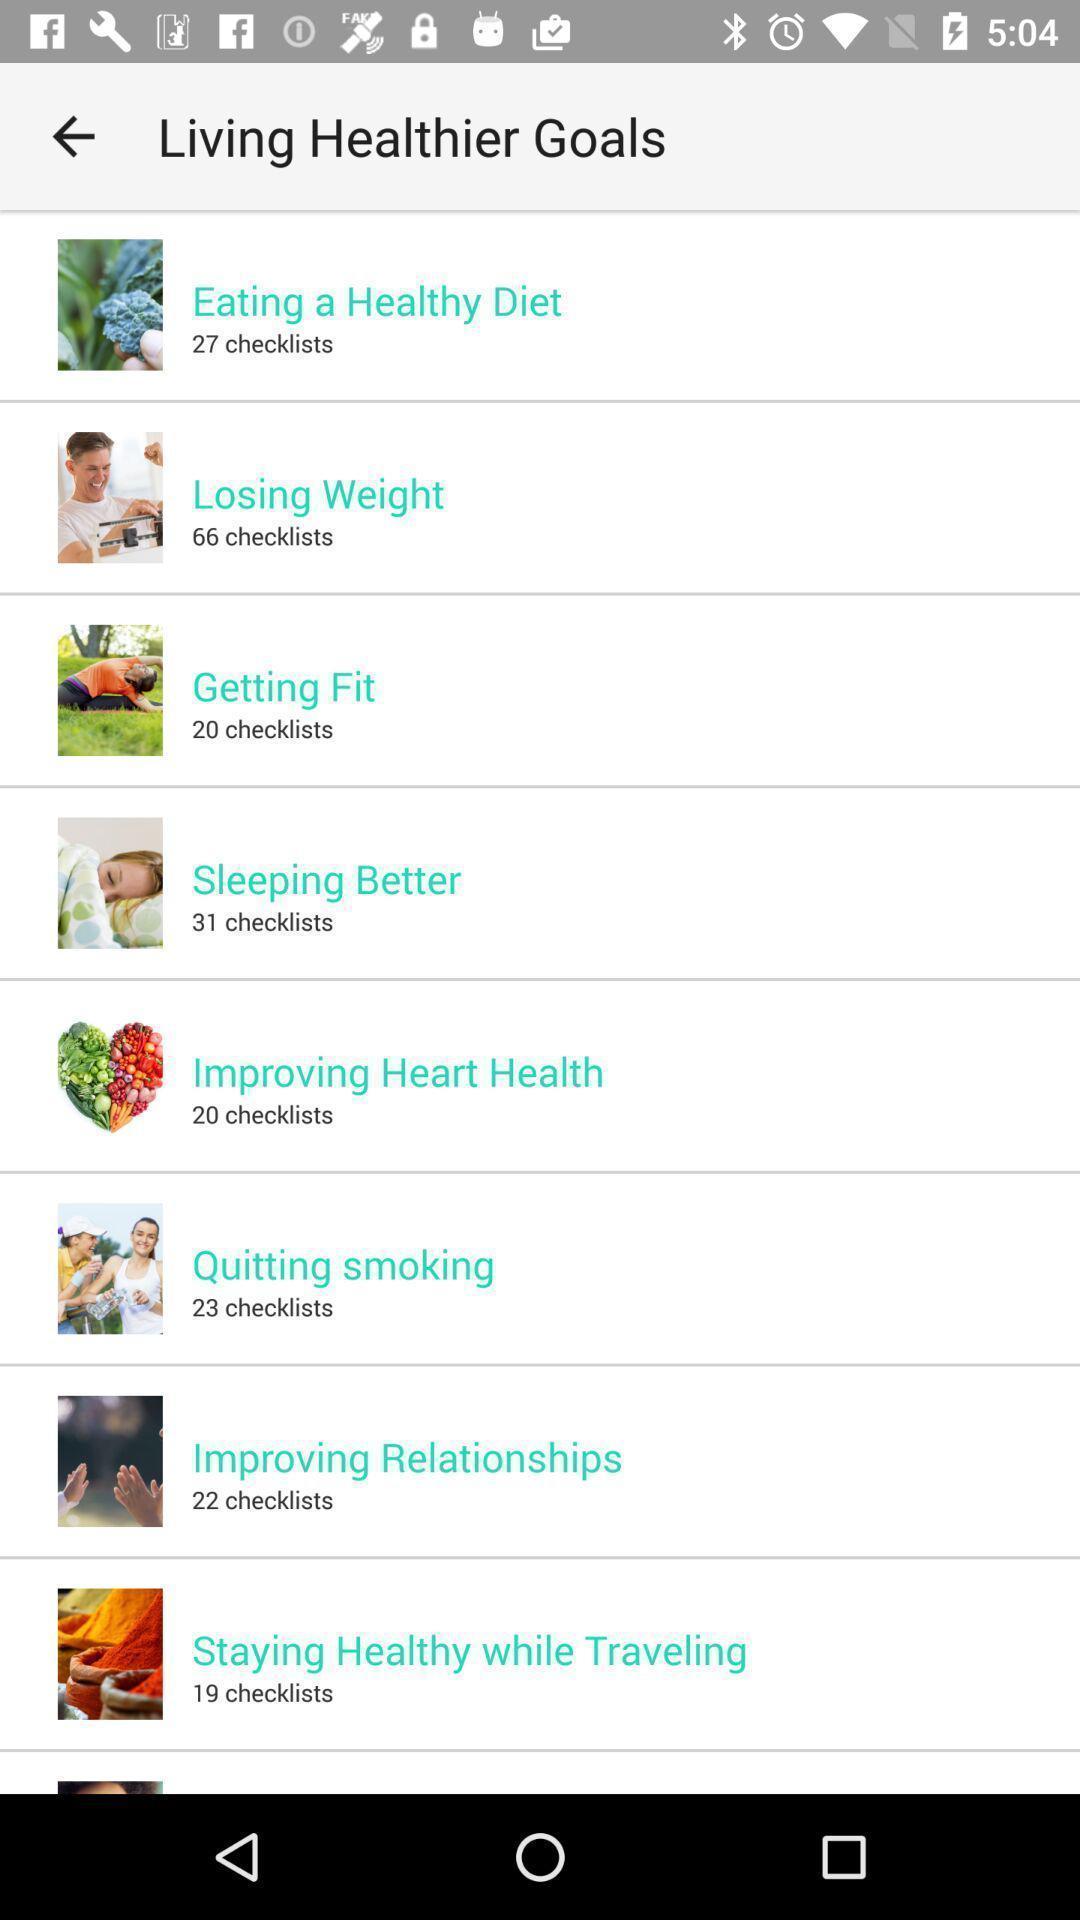Please provide a description for this image. Screen displaying list of contents on health care app. 